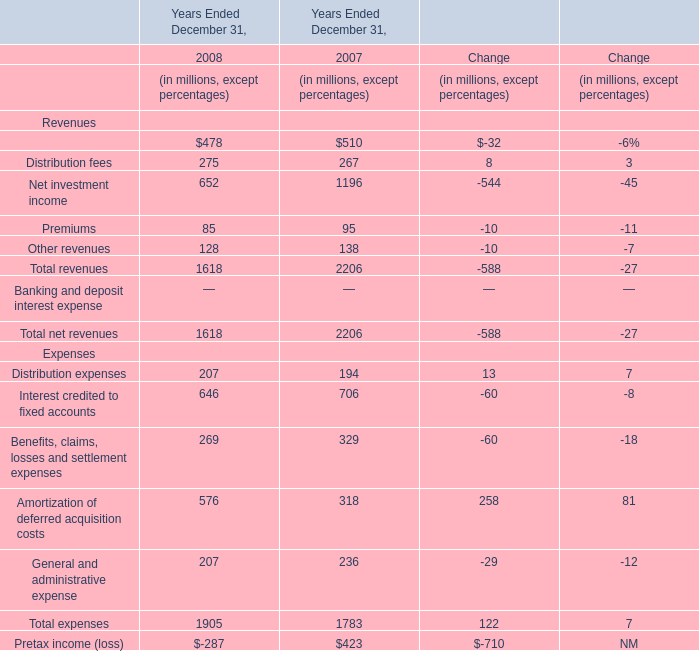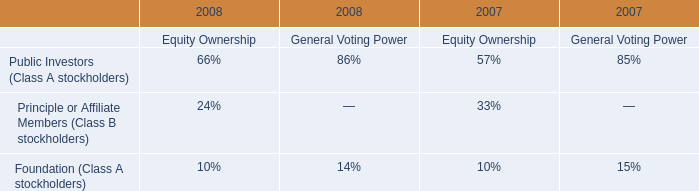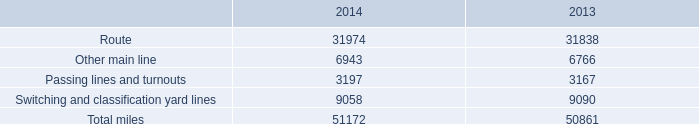What's the greatest value of revenues in 2008? (in millions) 
Answer: 478. 